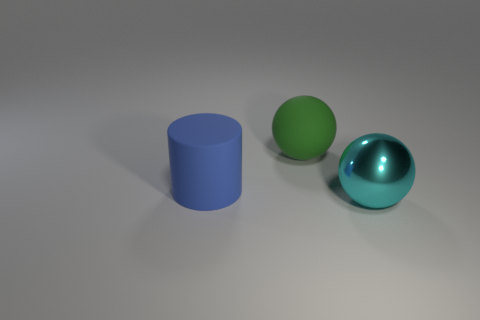How many things are in front of the big blue cylinder and to the left of the big cyan shiny thing?
Your response must be concise. 0. What shape is the big blue thing that is the same material as the big green thing?
Your response must be concise. Cylinder. There is a rubber object that is in front of the matte ball; is its size the same as the object in front of the big cylinder?
Provide a short and direct response. Yes. What is the color of the large matte object to the right of the rubber cylinder?
Provide a succinct answer. Green. What material is the big ball to the left of the ball that is in front of the big blue rubber object?
Ensure brevity in your answer.  Rubber. What is the shape of the green rubber object?
Ensure brevity in your answer.  Sphere. There is another big object that is the same shape as the large cyan thing; what is it made of?
Keep it short and to the point. Rubber. How many things have the same size as the blue rubber cylinder?
Offer a terse response. 2. There is a ball that is on the left side of the large cyan shiny object; is there a large blue matte thing in front of it?
Offer a very short reply. Yes. How many red objects are either big rubber balls or small cylinders?
Your answer should be very brief. 0. 